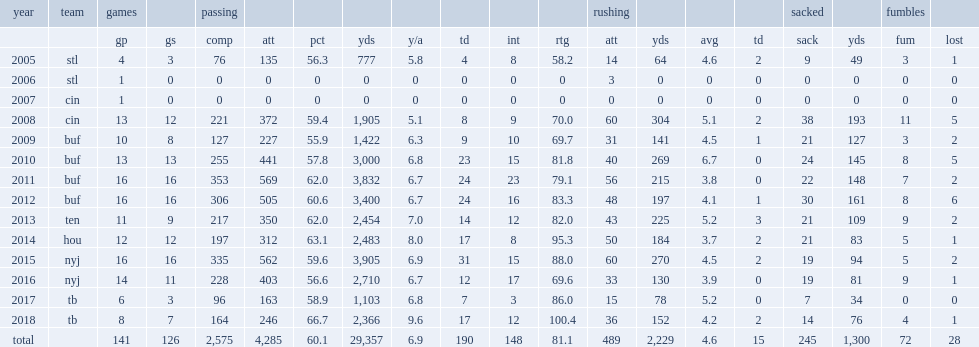How many passing yards did fitzpatrick have in 2009? 1422.0. How many games did fitzpatrick have totally? 126.0. 